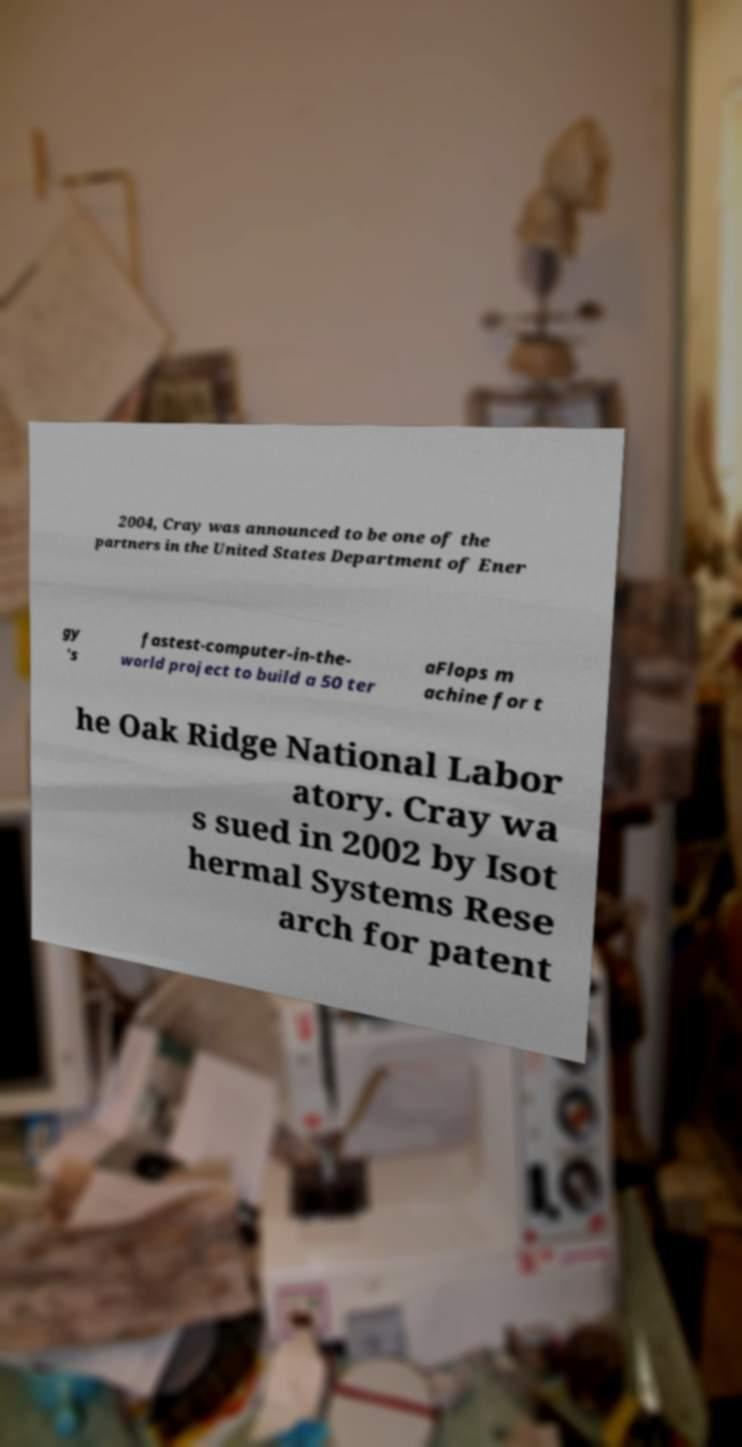Please read and relay the text visible in this image. What does it say? 2004, Cray was announced to be one of the partners in the United States Department of Ener gy 's fastest-computer-in-the- world project to build a 50 ter aFlops m achine for t he Oak Ridge National Labor atory. Cray wa s sued in 2002 by Isot hermal Systems Rese arch for patent 